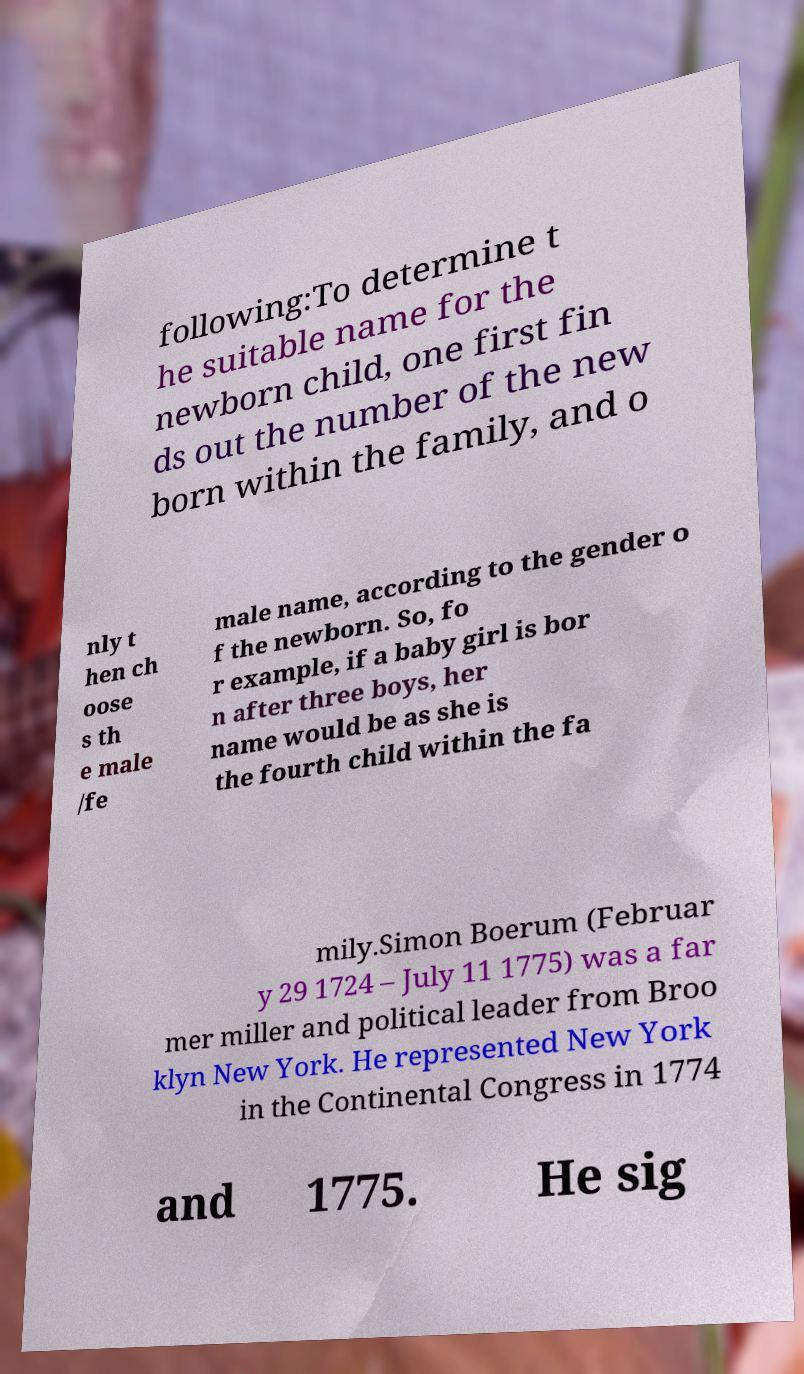For documentation purposes, I need the text within this image transcribed. Could you provide that? following:To determine t he suitable name for the newborn child, one first fin ds out the number of the new born within the family, and o nly t hen ch oose s th e male /fe male name, according to the gender o f the newborn. So, fo r example, if a baby girl is bor n after three boys, her name would be as she is the fourth child within the fa mily.Simon Boerum (Februar y 29 1724 – July 11 1775) was a far mer miller and political leader from Broo klyn New York. He represented New York in the Continental Congress in 1774 and 1775. He sig 